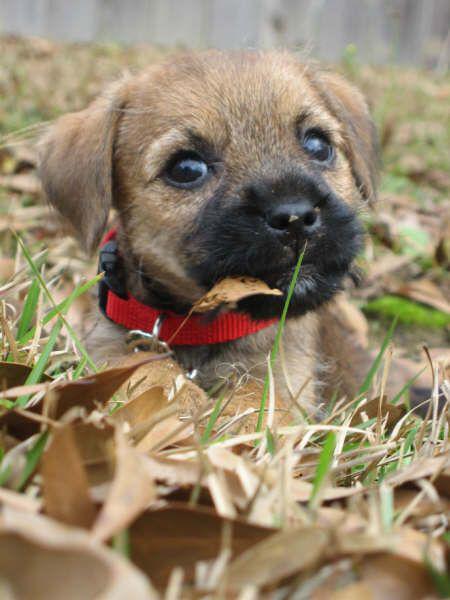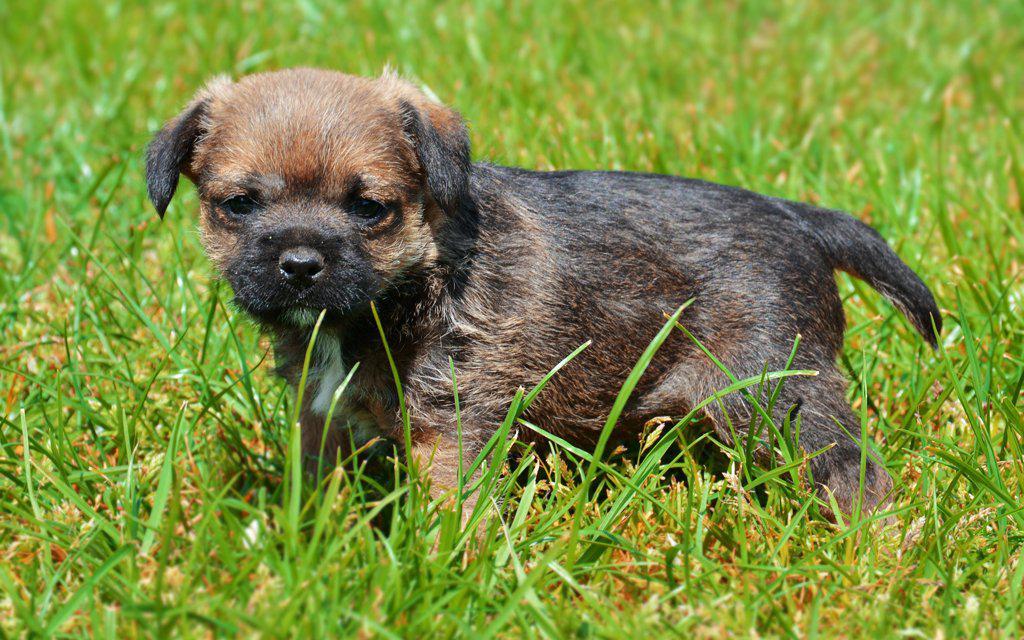The first image is the image on the left, the second image is the image on the right. Given the left and right images, does the statement "A collar is visible on the dog in one of the images." hold true? Answer yes or no. Yes. 